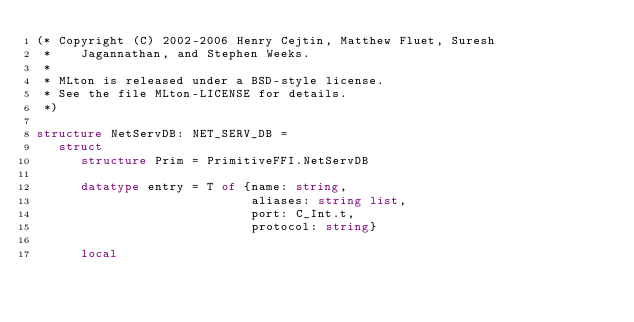Convert code to text. <code><loc_0><loc_0><loc_500><loc_500><_SML_>(* Copyright (C) 2002-2006 Henry Cejtin, Matthew Fluet, Suresh
 *    Jagannathan, and Stephen Weeks.
 *
 * MLton is released under a BSD-style license.
 * See the file MLton-LICENSE for details.
 *)

structure NetServDB: NET_SERV_DB =
   struct
      structure Prim = PrimitiveFFI.NetServDB

      datatype entry = T of {name: string,
                             aliases: string list,
                             port: C_Int.t,
                             protocol: string}

      local</code> 